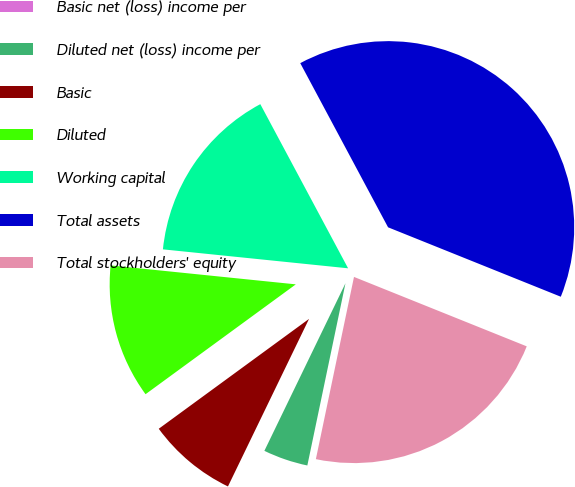Convert chart. <chart><loc_0><loc_0><loc_500><loc_500><pie_chart><fcel>Basic net (loss) income per<fcel>Diluted net (loss) income per<fcel>Basic<fcel>Diluted<fcel>Working capital<fcel>Total assets<fcel>Total stockholders' equity<nl><fcel>0.0%<fcel>3.89%<fcel>7.78%<fcel>11.67%<fcel>15.56%<fcel>38.9%<fcel>22.2%<nl></chart> 